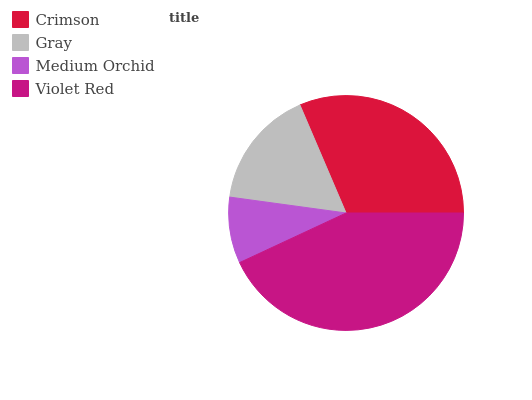Is Medium Orchid the minimum?
Answer yes or no. Yes. Is Violet Red the maximum?
Answer yes or no. Yes. Is Gray the minimum?
Answer yes or no. No. Is Gray the maximum?
Answer yes or no. No. Is Crimson greater than Gray?
Answer yes or no. Yes. Is Gray less than Crimson?
Answer yes or no. Yes. Is Gray greater than Crimson?
Answer yes or no. No. Is Crimson less than Gray?
Answer yes or no. No. Is Crimson the high median?
Answer yes or no. Yes. Is Gray the low median?
Answer yes or no. Yes. Is Violet Red the high median?
Answer yes or no. No. Is Crimson the low median?
Answer yes or no. No. 